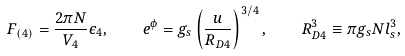Convert formula to latex. <formula><loc_0><loc_0><loc_500><loc_500>F _ { ( 4 ) } = \frac { 2 \pi N } { V _ { 4 } } { \epsilon } _ { 4 } , \quad e ^ { \phi } = g _ { s } \left ( \frac { u } { R _ { D 4 } } \right ) ^ { 3 / 4 } , \quad R _ { D 4 } ^ { 3 } \equiv \pi g _ { s } N l _ { s } ^ { 3 } ,</formula> 